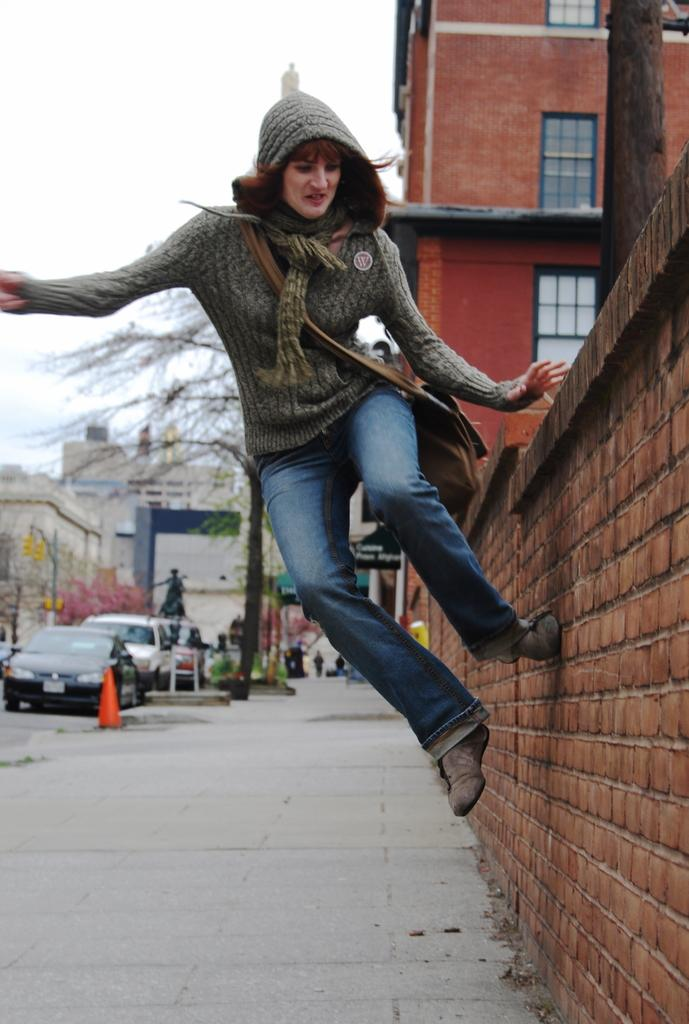What type of structure can be seen in the image? There is a building in the image. What other architectural feature is present in the image? There is a wall in the image. Can you describe the person visible in the image? A person is visible in the image. What is located on the left side of the image? There are buildings and vehicles on the left side of the image. What type of vegetation can be seen in the image? There are trees visible in the image. What is visible at the top of the image? The sky is visible at the top of the image. Where is the baby hiding in the image? There is no baby present in the image. What type of trick is being performed by the person in the image? There is no trick being performed by the person in the image. 